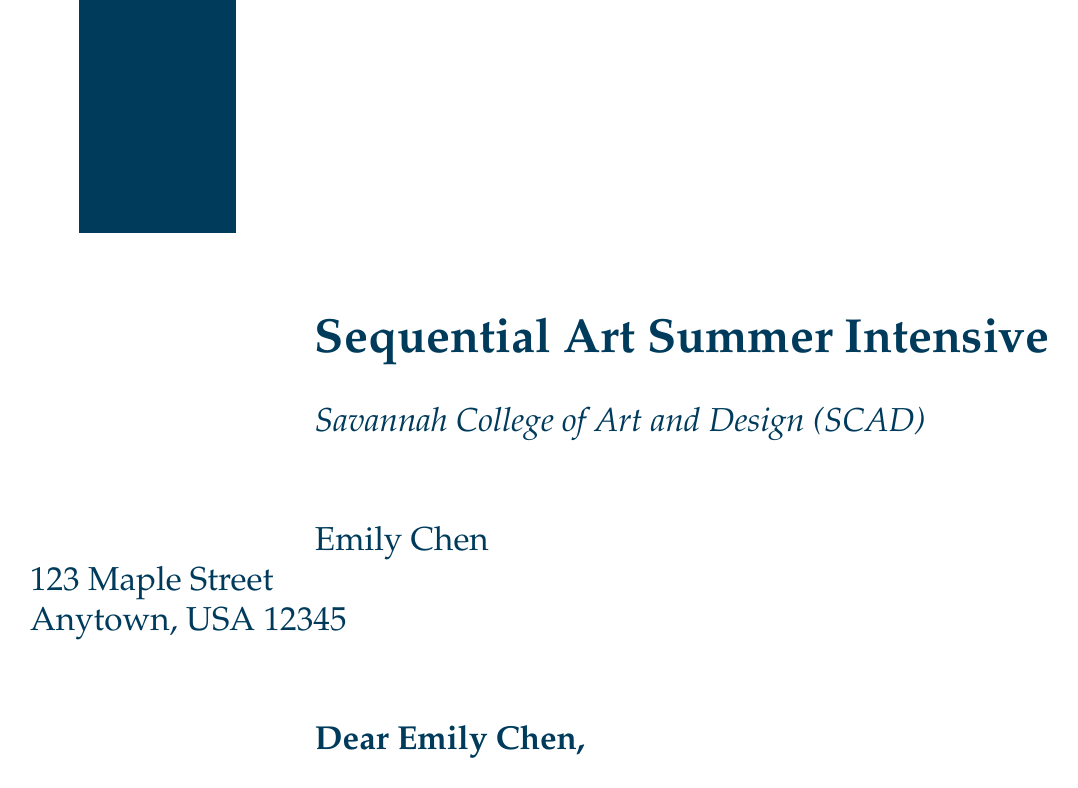What is the name of the program? The program is called "Sequential Art Summer Intensive."
Answer: Sequential Art Summer Intensive Who is the institution offering the program? The institution offering the program is Savannah College of Art and Design (SCAD).
Answer: Savannah College of Art and Design (SCAD) What are the program dates? The program lasts from July 5 to August 1, 2023.
Answer: July 5 to August 1, 2023 What is the program fee? The program fee is $3,500.
Answer: $3,500 Who are two industry professionals mentioned in the document? The document mentions Marjorie Liu and Fiona Staples as industry professionals leading workshops.
Answer: Marjorie Liu and Fiona Staples What is required to be completed by May 15, 2023? The enclosed enrollment form must be completed and returned by that date.
Answer: Enrollment form What type of accommodation is provided? The accommodation is an on-campus dormitory.
Answer: On-campus dormitory What should participants bring for inspiration? Participants should bring their favorite graphic novels for inspiration.
Answer: Favorite graphic novels What is the virtual orientation session date? The virtual orientation session is on June 20, 2023.
Answer: June 20, 2023 Who should be contacted for questions? The program coordinator, Sarah Thompson, should be contacted for questions.
Answer: Sarah Thompson 